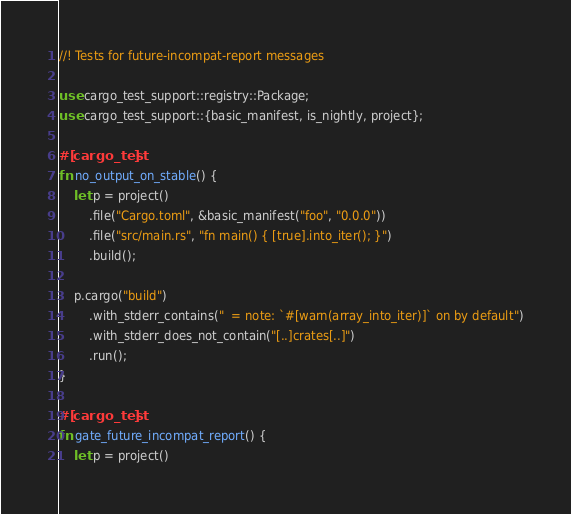Convert code to text. <code><loc_0><loc_0><loc_500><loc_500><_Rust_>//! Tests for future-incompat-report messages

use cargo_test_support::registry::Package;
use cargo_test_support::{basic_manifest, is_nightly, project};

#[cargo_test]
fn no_output_on_stable() {
    let p = project()
        .file("Cargo.toml", &basic_manifest("foo", "0.0.0"))
        .file("src/main.rs", "fn main() { [true].into_iter(); }")
        .build();

    p.cargo("build")
        .with_stderr_contains("  = note: `#[warn(array_into_iter)]` on by default")
        .with_stderr_does_not_contain("[..]crates[..]")
        .run();
}

#[cargo_test]
fn gate_future_incompat_report() {
    let p = project()</code> 